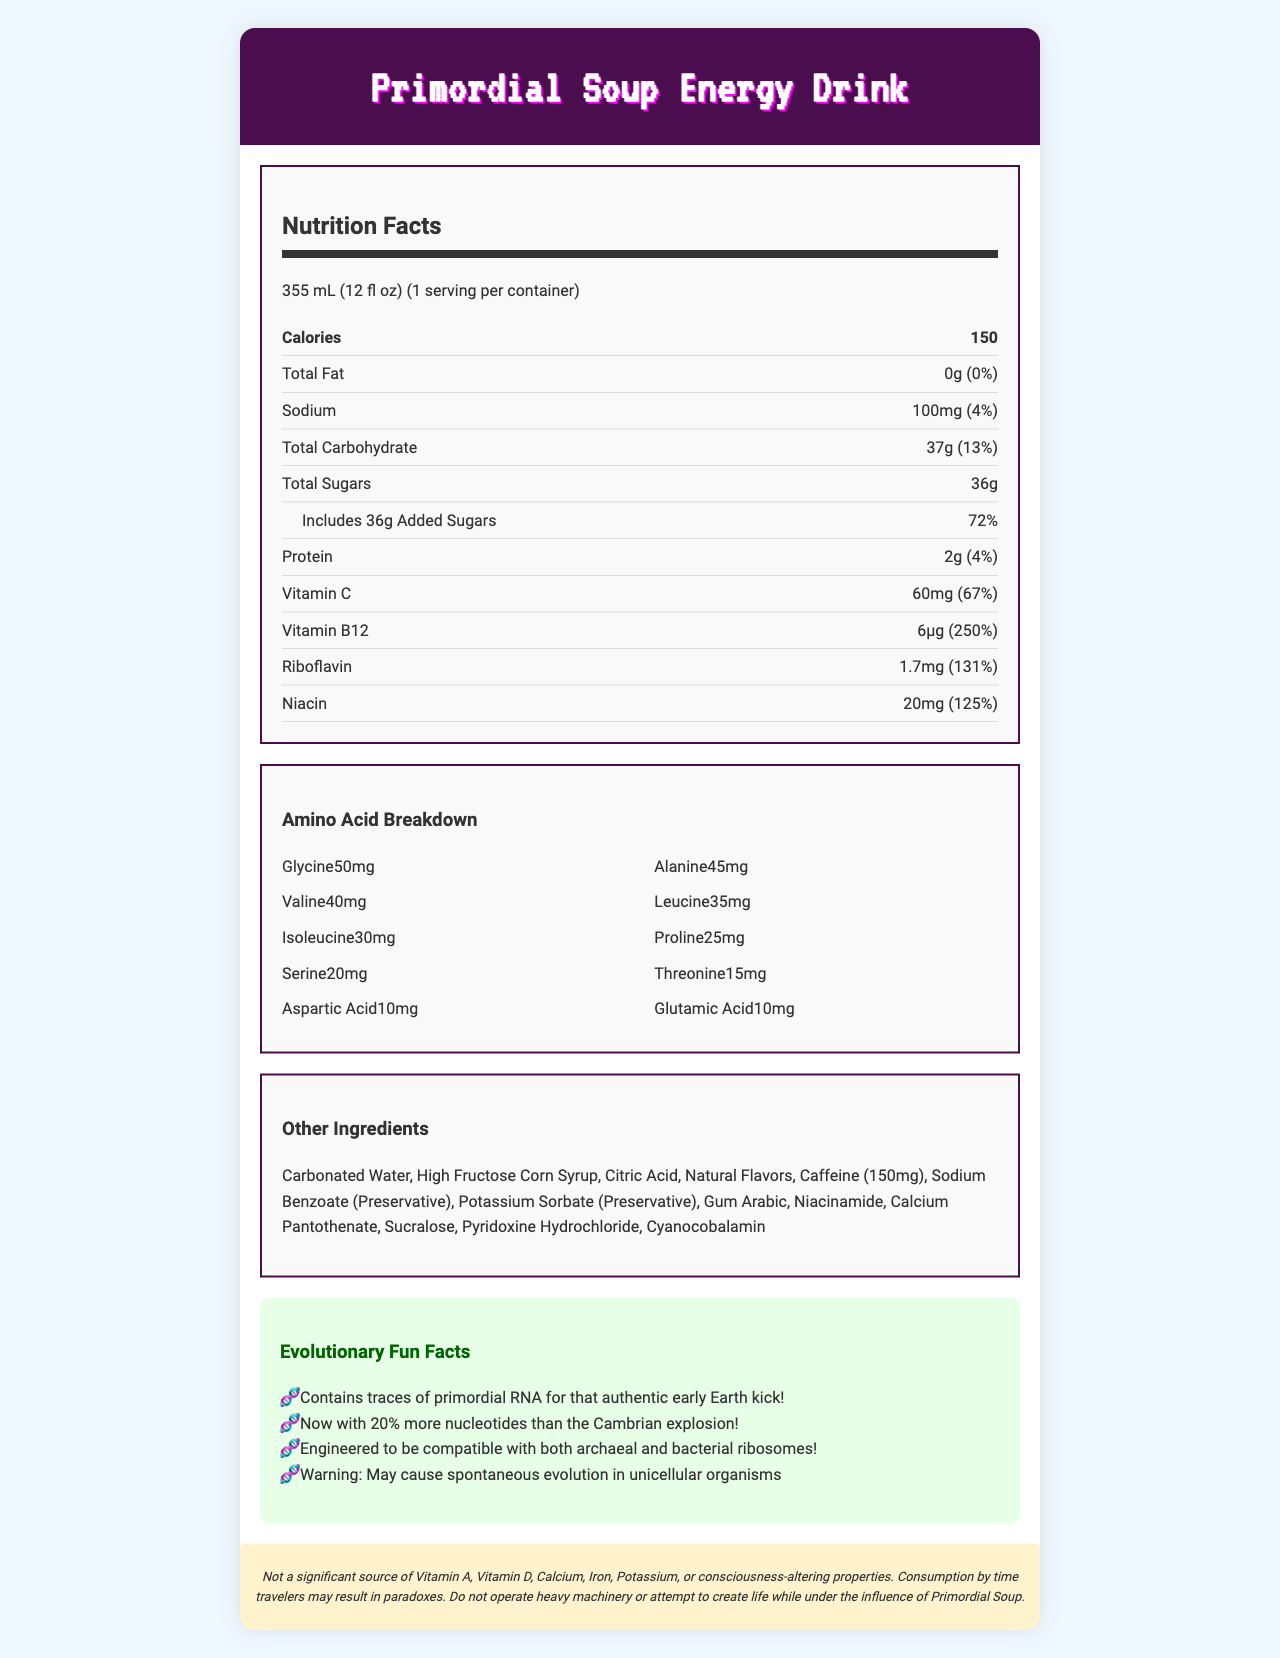what is the serving size? The serving size is listed at the beginning of the Nutrition Facts section.
Answer: 355 mL (12 fl oz) how many calories are in one serving of Primordial Soup Energy Drink? The document specifies the calorie content as 150.
Answer: 150 what is the total carbohydrate content? The total carbohydrate content is mentioned clearly in the Nutrition Facts section.
Answer: 37g how much vitamin C does one serving provide? The amount of Vitamin C is explicitly stated as 60mg.
Answer: 60mg who should avoid creating life while consuming Primordial Soup? The disclaimer states, "Do not operate heavy machinery or attempt to create life while under the influence of Primordial Soup".
Answer: People consuming the drink how many grams of added sugars are in the drink? The entry under total sugars indicates that there are 36 grams of added sugars.
Answer: 36g which of the following amino acids has the highest content in Primordial Soup Energy Drink? A. Glycine B. Alanine C. Leucine The document lists Glycine at 50mg, which is higher than Alanine (45mg) and Leucine (35mg).
Answer: A. Glycine how much caffeine is included in the drink? The other ingredients section lists Caffeine with a specific amount of 150mg.
Answer: 150mg is the Primordial Soup Energy Drink a significant source of Vitamin A? The disclaimer at the bottom of the document mentions that it is not a significant source of Vitamin A.
Answer: No which vitamin has the highest daily value percentage in the drink? A. Vitamin C B. Riboflavin C. Vitamin B12 D. Niacin Vitamin B12 has a daily value percentage of 250%, which is higher than Vitamin C (67%), Riboflavin (131%), and Niacin (125%).
Answer: C. Vitamin B12 is the Primordial Soup suitable for people with sodium-restricted diets? The drink contains 100mg of sodium, which is 4% of the daily value. People on sodium-restricted diets should pay attention to this.
Answer: Possibly not what is the main idea of the Nutrition Facts Label for Primordial Soup Energy Drink? The label includes detailed information on calorie content, macronutrients, vitamins, amino acids, other ingredients, and interesting evolutionary fun facts, along with a humorous disclaimer.
Answer: The document provides comprehensive nutritional information, amino acid breakdown, and fun evolutionary facts about the Primordial Soup Energy Drink. how many essential amino acids are listed in the breakdown? The document lists various amino acids but does not specify which are essential amino acids, so this cannot be determined from the provided information.
Answer: Cannot be determined 